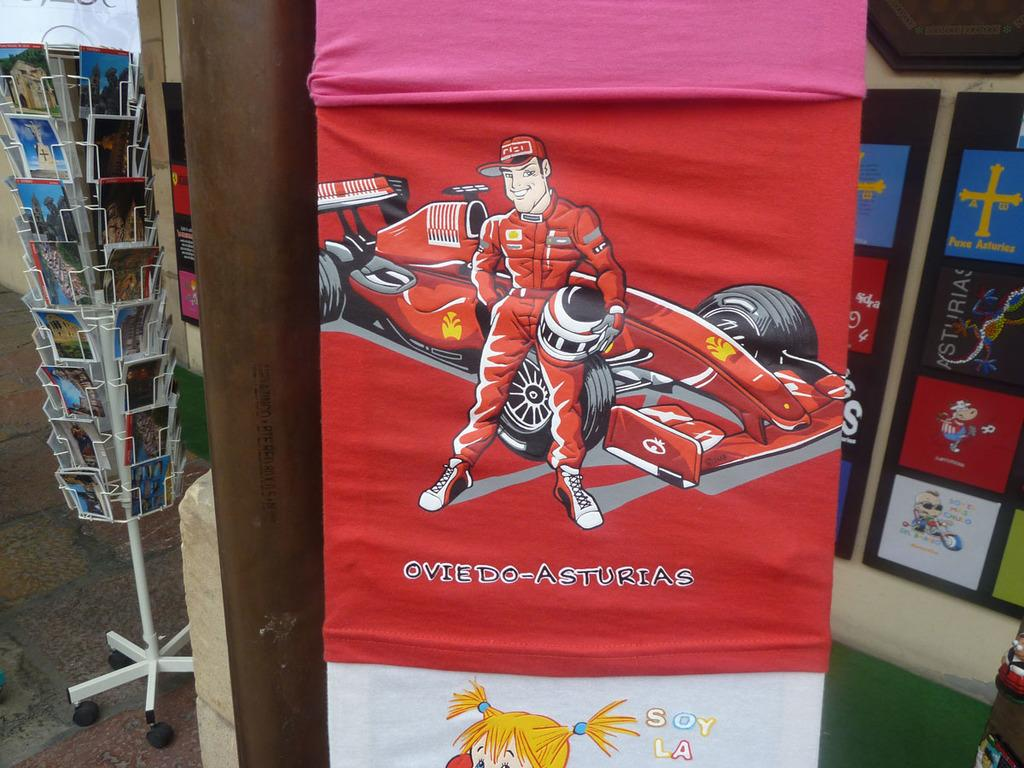What is hanging near a pipe in the image? There are clothes hanging near a pipe in the image. What can be seen on the left side of the image? There are many books on steel racks on the left side of the image. What is present on the right side of the image? There are frames on the wall on the right side of the image. What type of lip can be seen on the quartz in the image? There is no lip or quartz present in the image. What is the desire of the clothes hanging near the pipe? Clothes do not have desires, so this question cannot be answered. 